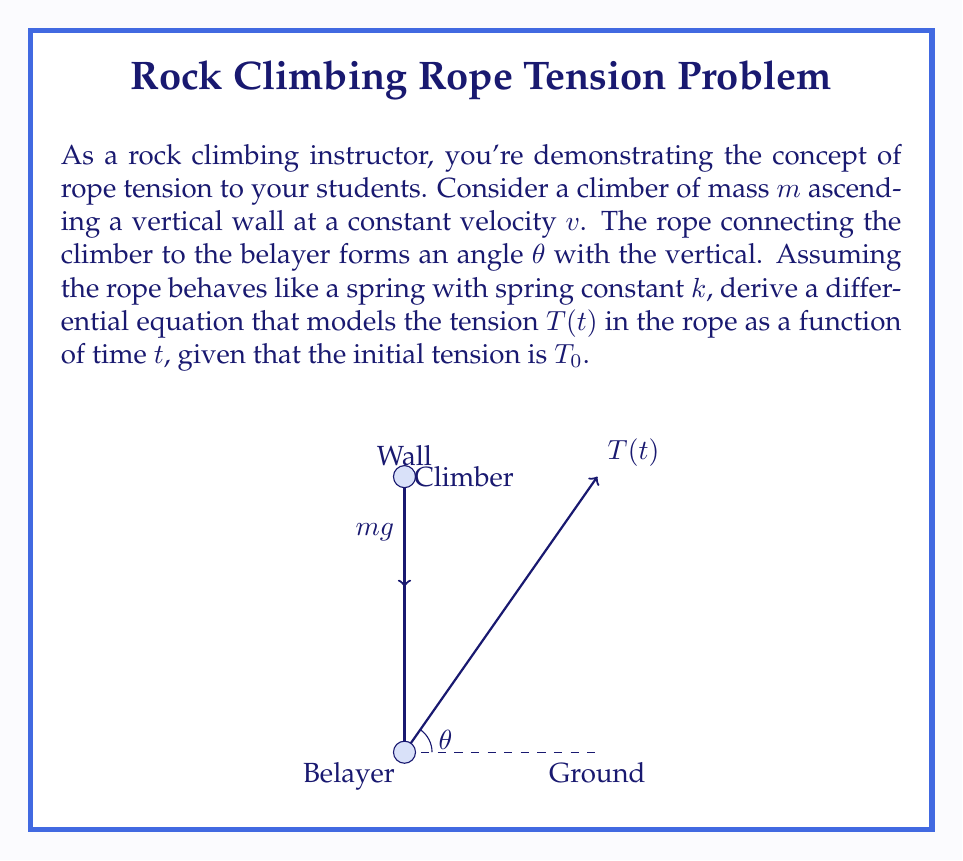Show me your answer to this math problem. Let's approach this step-by-step:

1) First, we need to consider the forces acting on the climber:
   - Gravity: $mg$ downward
   - Tension in the rope: $T(t)$ at an angle $\theta$ from vertical

2) Since the climber is moving at constant velocity, the net force must be zero (Newton's First Law). We can write this as:

   $$T(t)\cos\theta - mg = 0$$

3) Now, let's consider the extension of the rope. If $x(t)$ is the extension at time $t$, then:

   $$T(t) = kx(t)$$

4) The rate of change of the extension is related to the climber's velocity:

   $$\frac{dx}{dt} = v\cos\theta$$

5) Differentiating the equation from step 3 with respect to time:

   $$\frac{dT}{dt} = k\frac{dx}{dt} = kv\cos\theta$$

6) This gives us our differential equation:

   $$\frac{dT}{dt} = kv\cos\theta$$

7) To solve this, we integrate both sides:

   $$\int_{T_0}^T dT = \int_0^t kv\cos\theta dt$$

   $$T - T_0 = kv\cos\theta t$$

8) Therefore, the final equation for tension as a function of time is:

   $$T(t) = T_0 + kv\cos\theta t$$

This is a first-order linear differential equation with constant coefficients.
Answer: $$\frac{dT}{dt} = kv\cos\theta$$ 